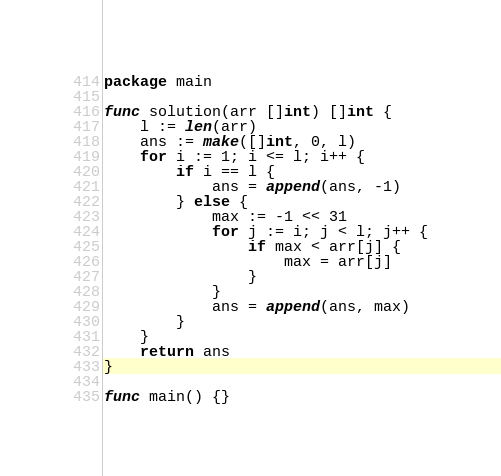<code> <loc_0><loc_0><loc_500><loc_500><_Go_>package main

func solution(arr []int) []int {
	l := len(arr)
	ans := make([]int, 0, l)
	for i := 1; i <= l; i++ {
		if i == l {
			ans = append(ans, -1)
		} else {
			max := -1 << 31
			for j := i; j < l; j++ {
				if max < arr[j] {
					max = arr[j]
				}
			}
			ans = append(ans, max)
		}
	}
	return ans
}

func main() {}
</code> 